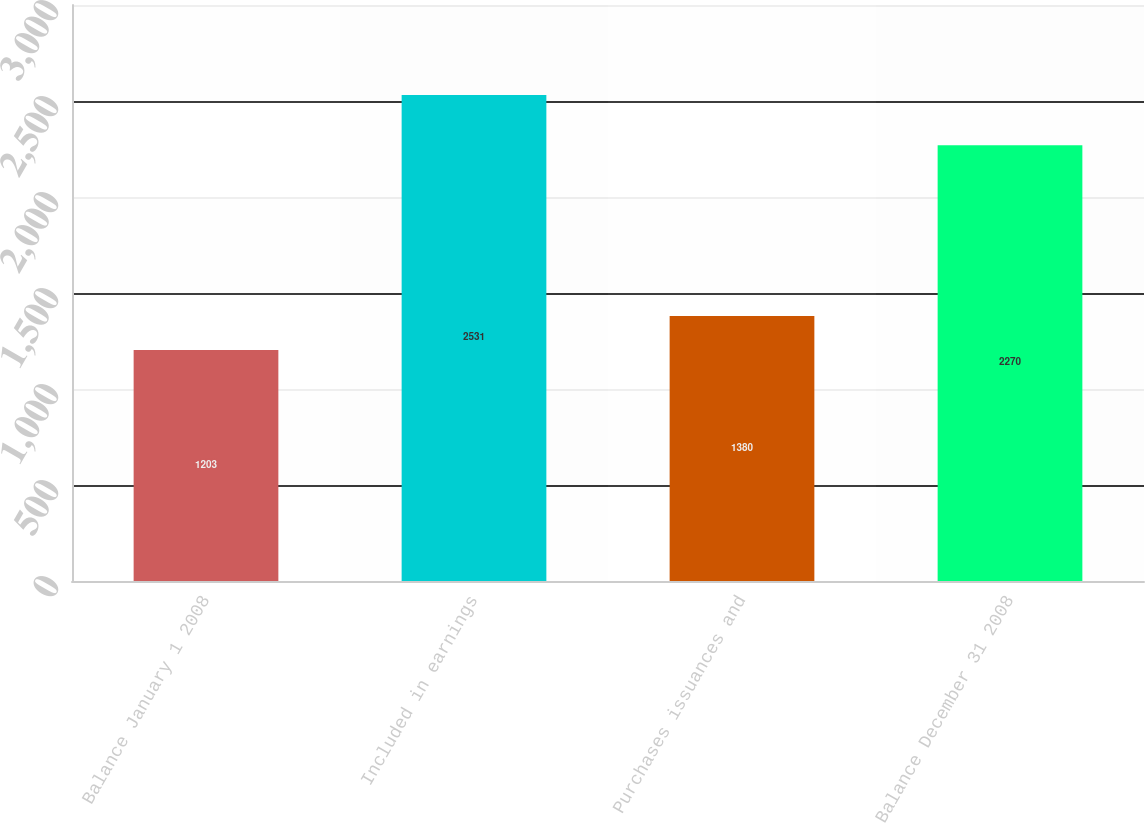Convert chart. <chart><loc_0><loc_0><loc_500><loc_500><bar_chart><fcel>Balance January 1 2008<fcel>Included in earnings<fcel>Purchases issuances and<fcel>Balance December 31 2008<nl><fcel>1203<fcel>2531<fcel>1380<fcel>2270<nl></chart> 